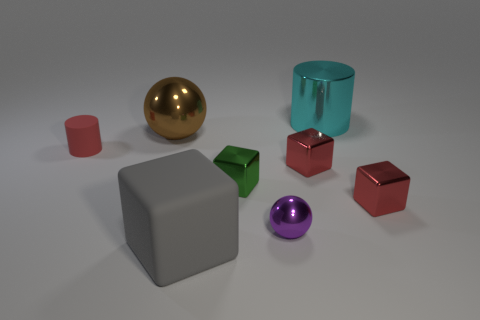Subtract all purple blocks. Subtract all purple cylinders. How many blocks are left? 4 Add 1 cyan objects. How many objects exist? 9 Subtract all balls. How many objects are left? 6 Subtract all big purple metallic objects. Subtract all small red metal things. How many objects are left? 6 Add 5 gray matte things. How many gray matte things are left? 6 Add 1 red rubber things. How many red rubber things exist? 2 Subtract 1 purple spheres. How many objects are left? 7 